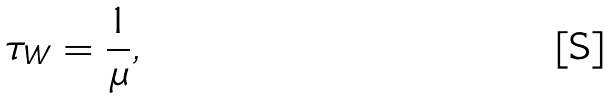Convert formula to latex. <formula><loc_0><loc_0><loc_500><loc_500>\tau _ { W } = \frac { 1 } { \mu } ,</formula> 